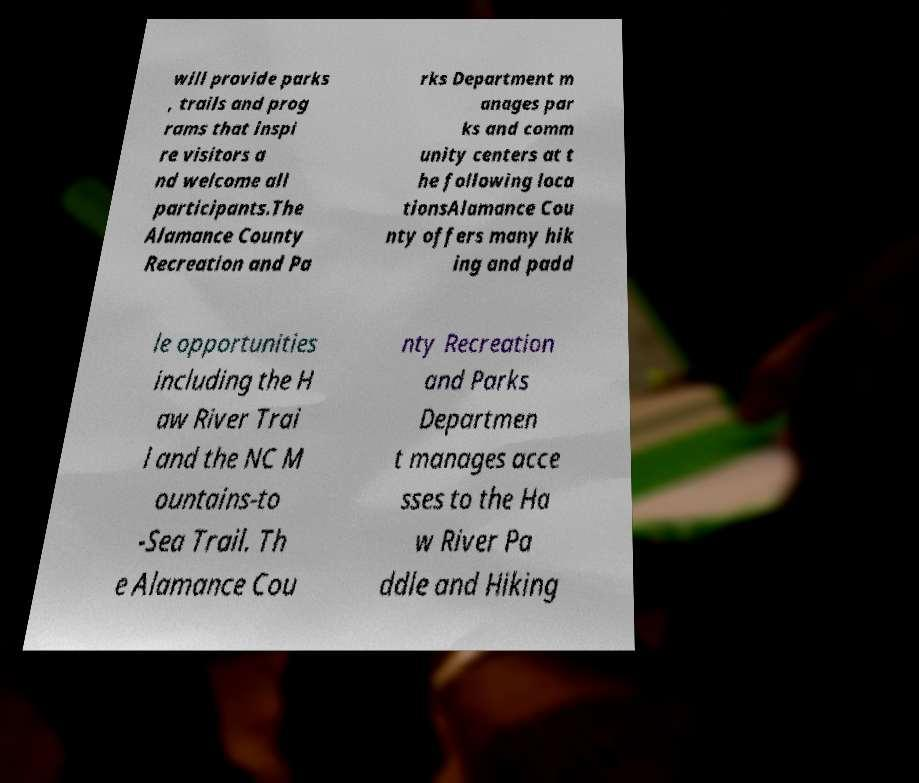Please identify and transcribe the text found in this image. will provide parks , trails and prog rams that inspi re visitors a nd welcome all participants.The Alamance County Recreation and Pa rks Department m anages par ks and comm unity centers at t he following loca tionsAlamance Cou nty offers many hik ing and padd le opportunities including the H aw River Trai l and the NC M ountains-to -Sea Trail. Th e Alamance Cou nty Recreation and Parks Departmen t manages acce sses to the Ha w River Pa ddle and Hiking 